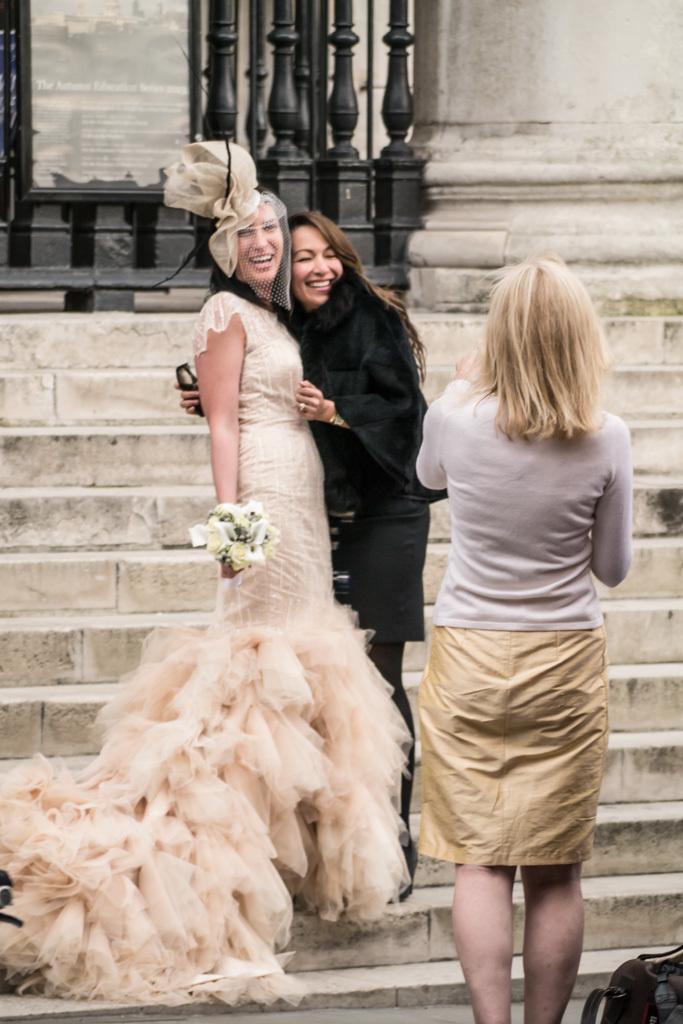Please provide a concise description of this image. In this image there is a person standing, and at the background there are two persons standing on the staircase , board. 